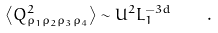Convert formula to latex. <formula><loc_0><loc_0><loc_500><loc_500>\left \langle Q _ { \rho _ { 1 } \rho _ { 2 } \rho _ { 3 } \rho _ { 4 } } ^ { 2 } \right \rangle \sim U ^ { 2 } L _ { 1 } ^ { - 3 d } \quad .</formula> 